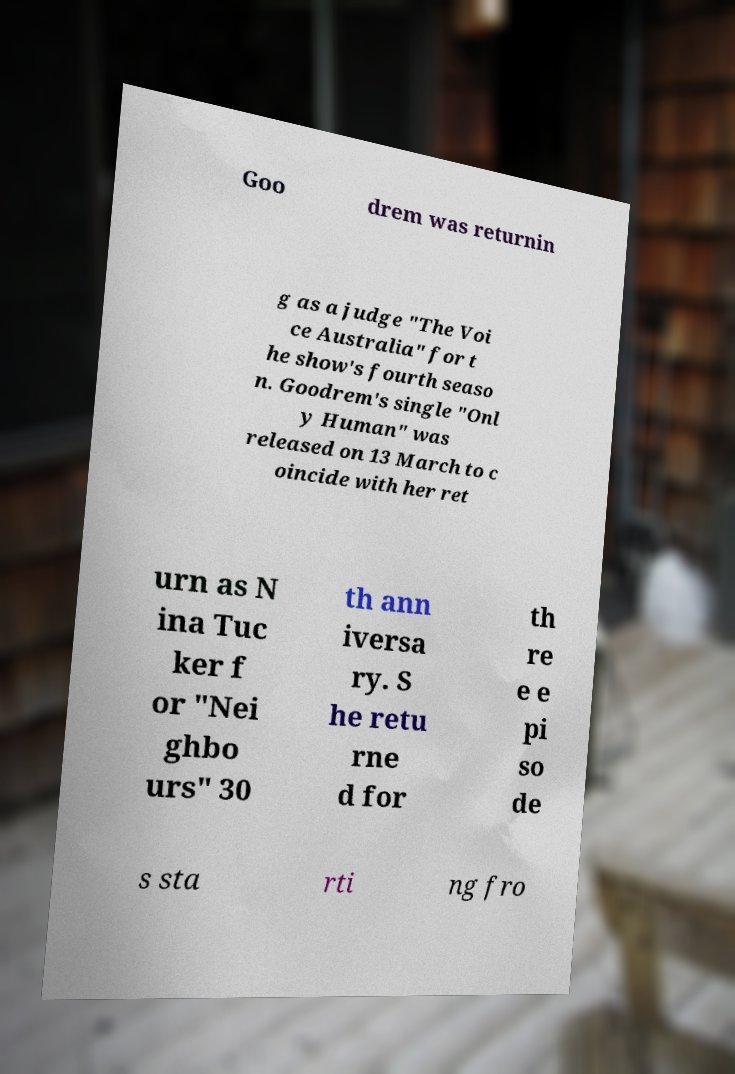Can you read and provide the text displayed in the image?This photo seems to have some interesting text. Can you extract and type it out for me? Goo drem was returnin g as a judge "The Voi ce Australia" for t he show's fourth seaso n. Goodrem's single "Onl y Human" was released on 13 March to c oincide with her ret urn as N ina Tuc ker f or "Nei ghbo urs" 30 th ann iversa ry. S he retu rne d for th re e e pi so de s sta rti ng fro 